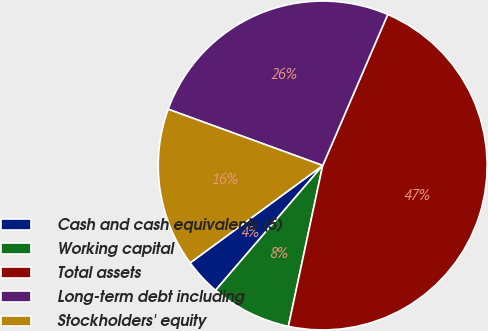Convert chart. <chart><loc_0><loc_0><loc_500><loc_500><pie_chart><fcel>Cash and cash equivalents (5)<fcel>Working capital<fcel>Total assets<fcel>Long-term debt including<fcel>Stockholders' equity<nl><fcel>3.63%<fcel>7.95%<fcel>46.87%<fcel>25.91%<fcel>15.64%<nl></chart> 